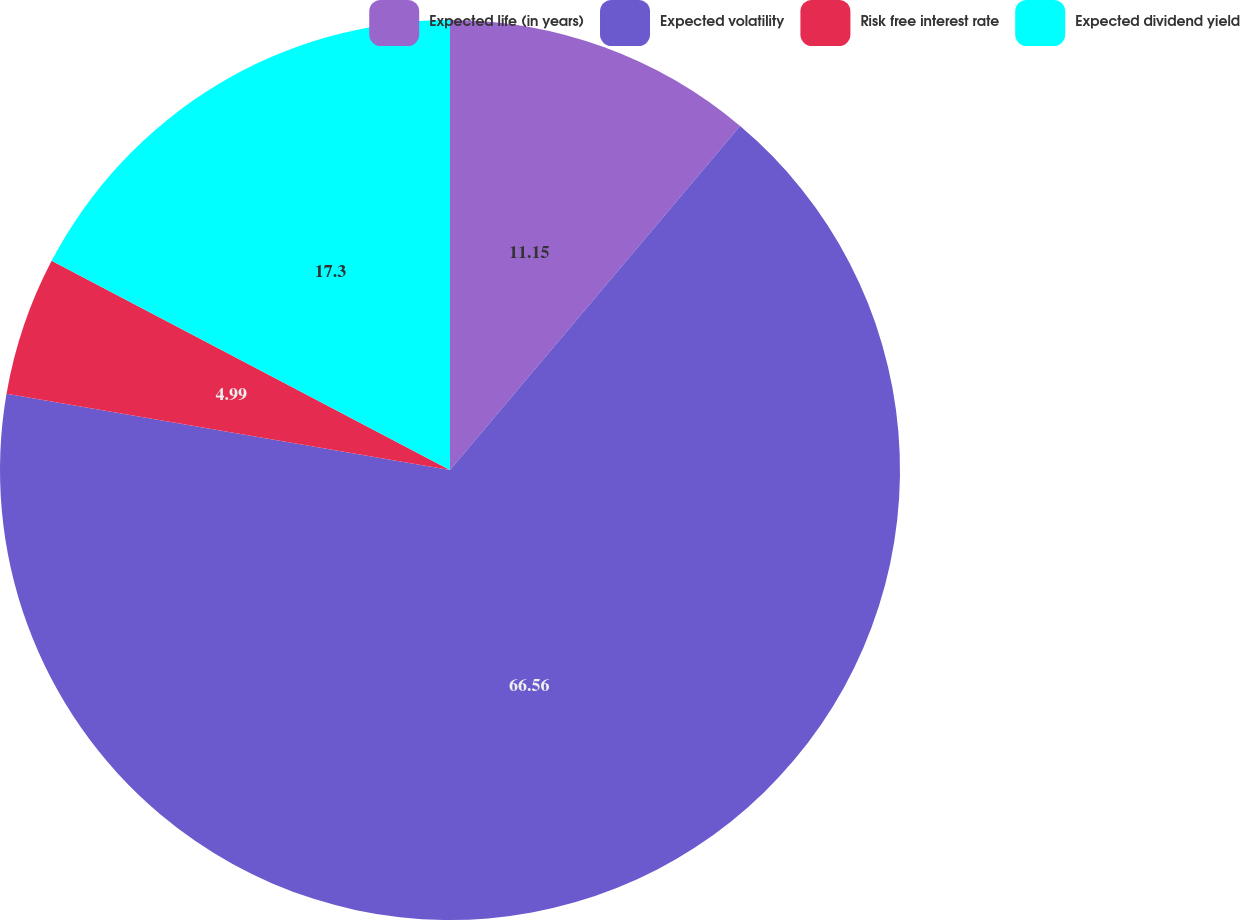Convert chart to OTSL. <chart><loc_0><loc_0><loc_500><loc_500><pie_chart><fcel>Expected life (in years)<fcel>Expected volatility<fcel>Risk free interest rate<fcel>Expected dividend yield<nl><fcel>11.15%<fcel>66.56%<fcel>4.99%<fcel>17.3%<nl></chart> 